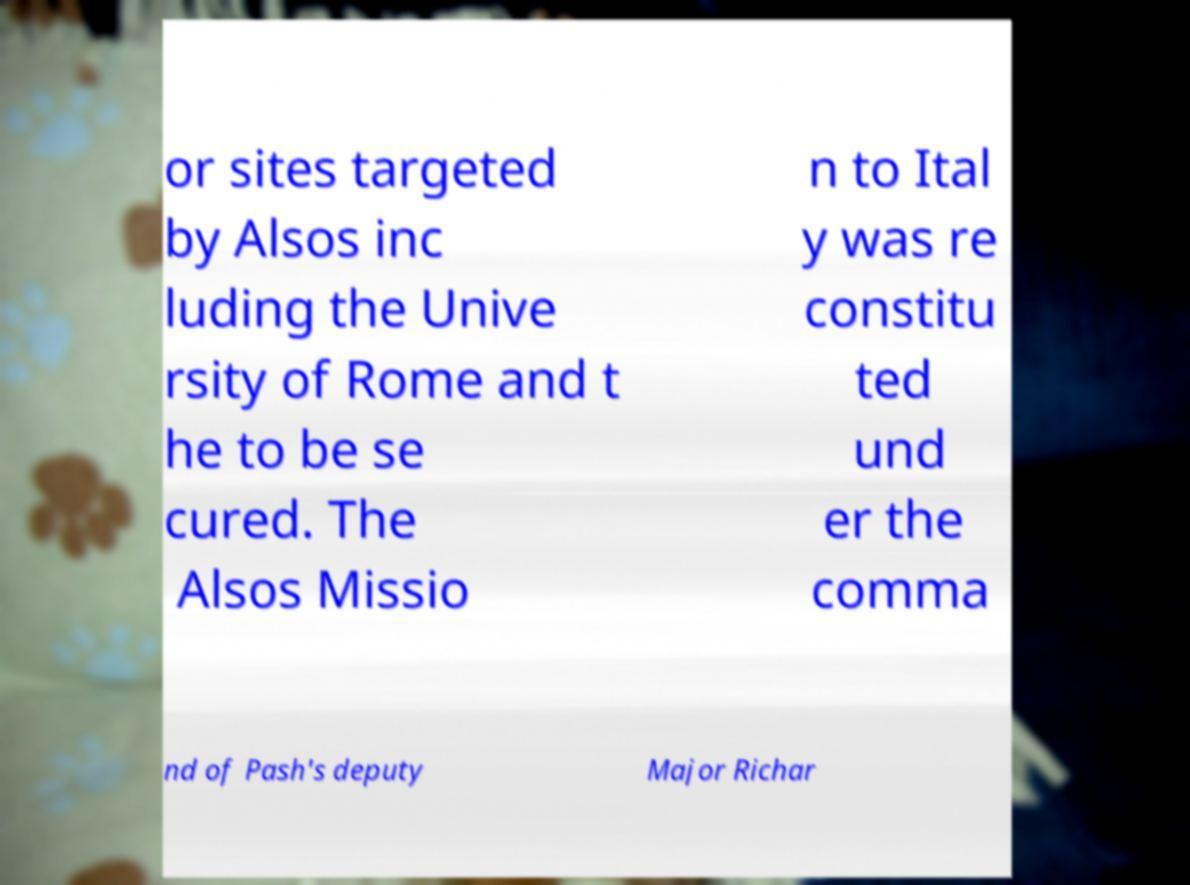I need the written content from this picture converted into text. Can you do that? or sites targeted by Alsos inc luding the Unive rsity of Rome and t he to be se cured. The Alsos Missio n to Ital y was re constitu ted und er the comma nd of Pash's deputy Major Richar 